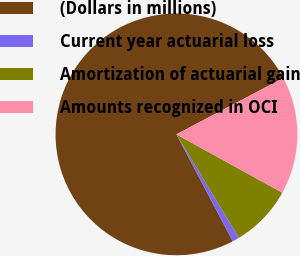Convert chart to OTSL. <chart><loc_0><loc_0><loc_500><loc_500><pie_chart><fcel>(Dollars in millions)<fcel>Current year actuarial loss<fcel>Amortization of actuarial gain<fcel>Amounts recognized in OCI<nl><fcel>74.99%<fcel>0.93%<fcel>8.34%<fcel>15.74%<nl></chart> 